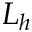Convert formula to latex. <formula><loc_0><loc_0><loc_500><loc_500>L _ { h }</formula> 